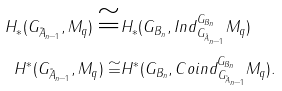<formula> <loc_0><loc_0><loc_500><loc_500>H _ { * } ( G _ { \tilde { A } _ { n - 1 } } , M _ { q } ) \cong & H _ { * } ( G _ { B _ { n } } , I n d _ { G _ { \tilde { A } _ { n - 1 } } } ^ { G _ { B _ { n } } } M _ { q } ) \\ H ^ { * } ( G _ { \tilde { A } _ { n - 1 } } , M _ { q } ) \cong & H ^ { * } ( G _ { B _ { n } } , C o i n d _ { G _ { \tilde { A } _ { n - 1 } } } ^ { G _ { B _ { n } } } M _ { q } ) .</formula> 